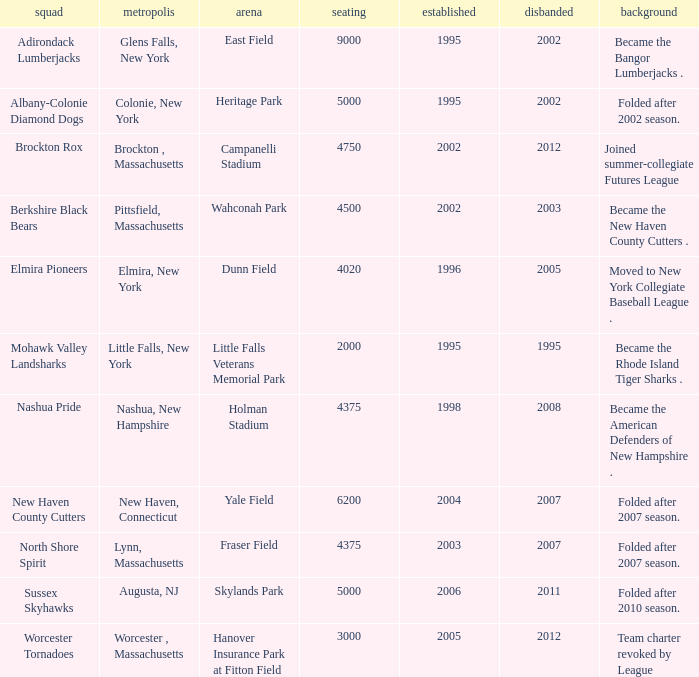What is the maximum founded year of the Worcester Tornadoes? 2005.0. 